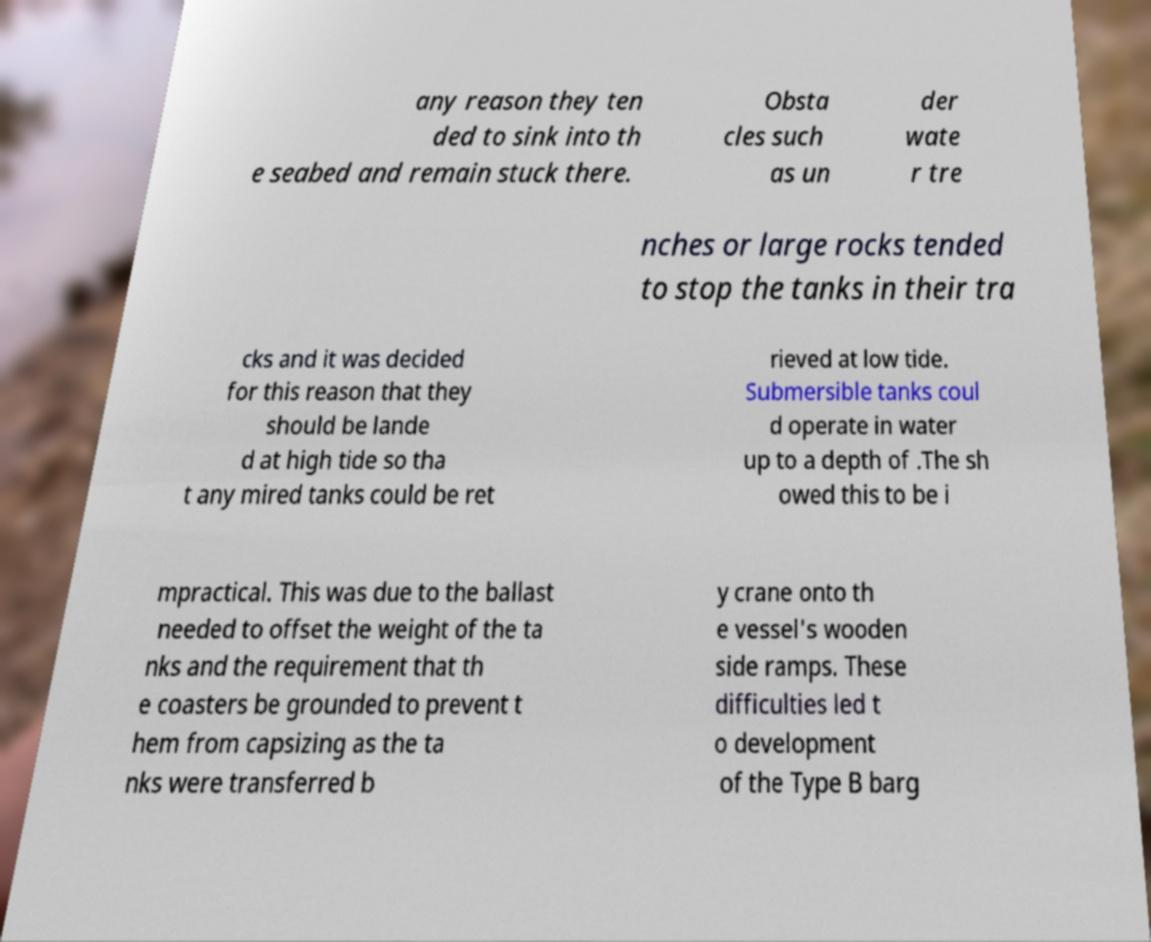Could you assist in decoding the text presented in this image and type it out clearly? any reason they ten ded to sink into th e seabed and remain stuck there. Obsta cles such as un der wate r tre nches or large rocks tended to stop the tanks in their tra cks and it was decided for this reason that they should be lande d at high tide so tha t any mired tanks could be ret rieved at low tide. Submersible tanks coul d operate in water up to a depth of .The sh owed this to be i mpractical. This was due to the ballast needed to offset the weight of the ta nks and the requirement that th e coasters be grounded to prevent t hem from capsizing as the ta nks were transferred b y crane onto th e vessel's wooden side ramps. These difficulties led t o development of the Type B barg 